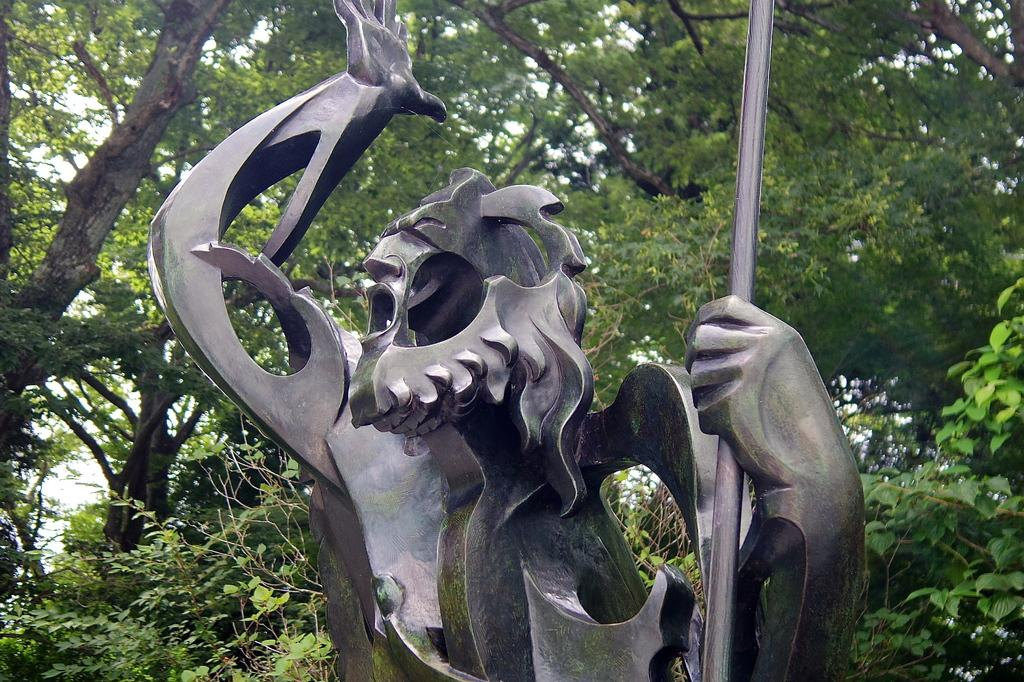What is the main subject of the image? There is a sculpture in the image. What can be seen in the background of the image? There are trees in the background of the image. What is the price of the sponge used to clean the sculpture in the image? There is no sponge or mention of cleaning the sculpture in the image, so it is not possible to determine the price of a sponge. 